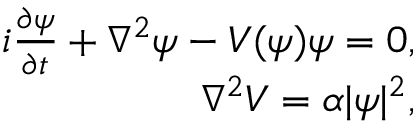Convert formula to latex. <formula><loc_0><loc_0><loc_500><loc_500>\begin{array} { r } { i \frac { \partial \psi } { \partial t } + \nabla ^ { 2 } \psi - V ( \psi ) \psi = 0 , } \\ { \nabla ^ { 2 } V = \alpha | \psi | ^ { 2 } , } \end{array}</formula> 